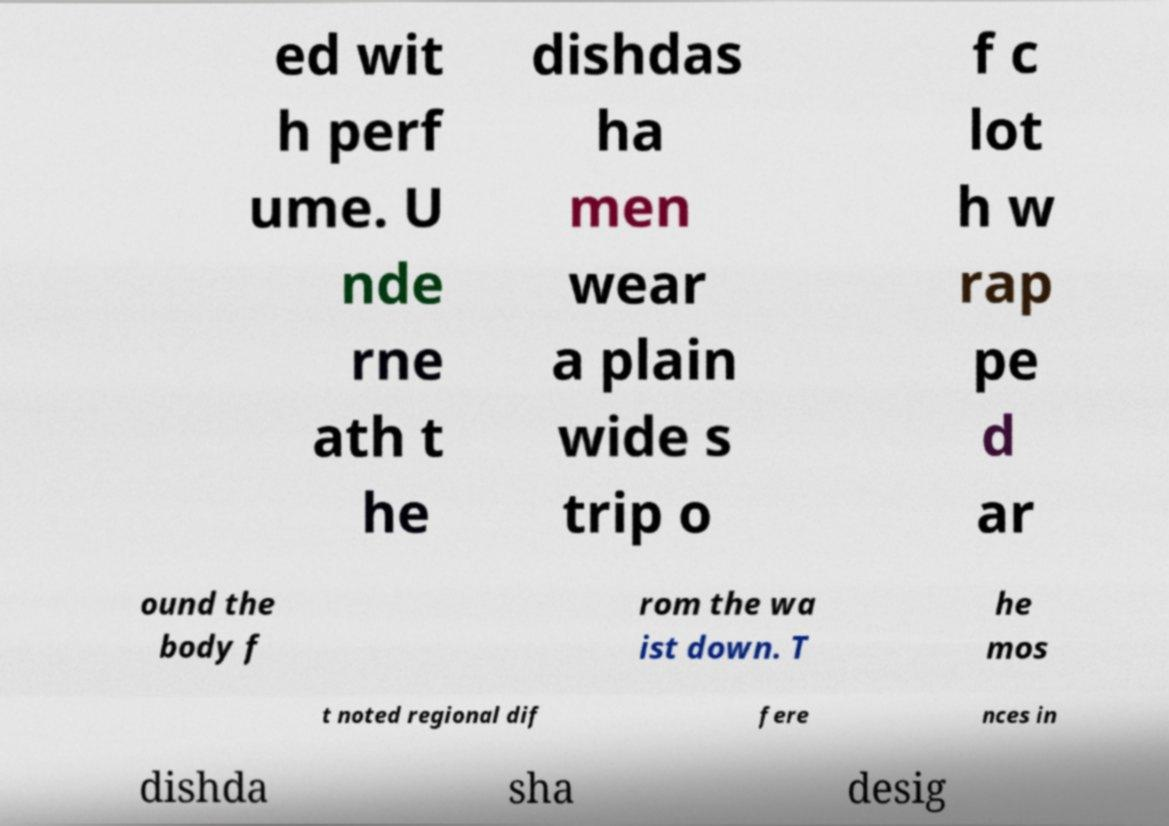Could you assist in decoding the text presented in this image and type it out clearly? ed wit h perf ume. U nde rne ath t he dishdas ha men wear a plain wide s trip o f c lot h w rap pe d ar ound the body f rom the wa ist down. T he mos t noted regional dif fere nces in dishda sha desig 